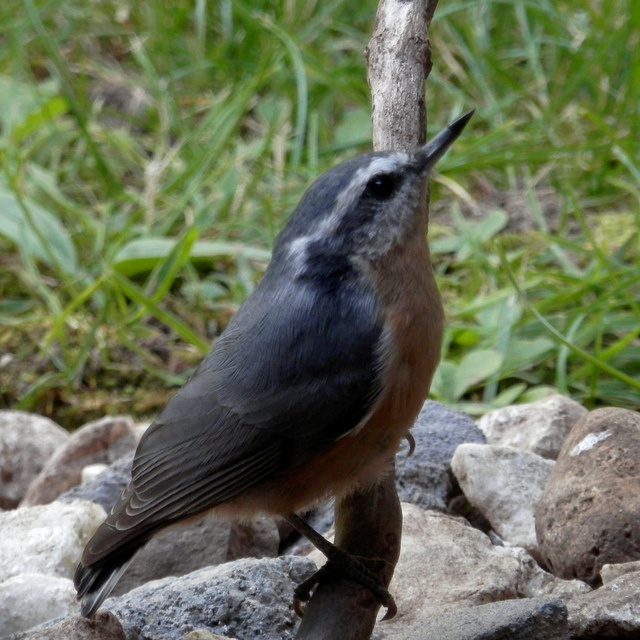Describe the objects in this image and their specific colors. I can see a bird in olive, black, and gray tones in this image. 